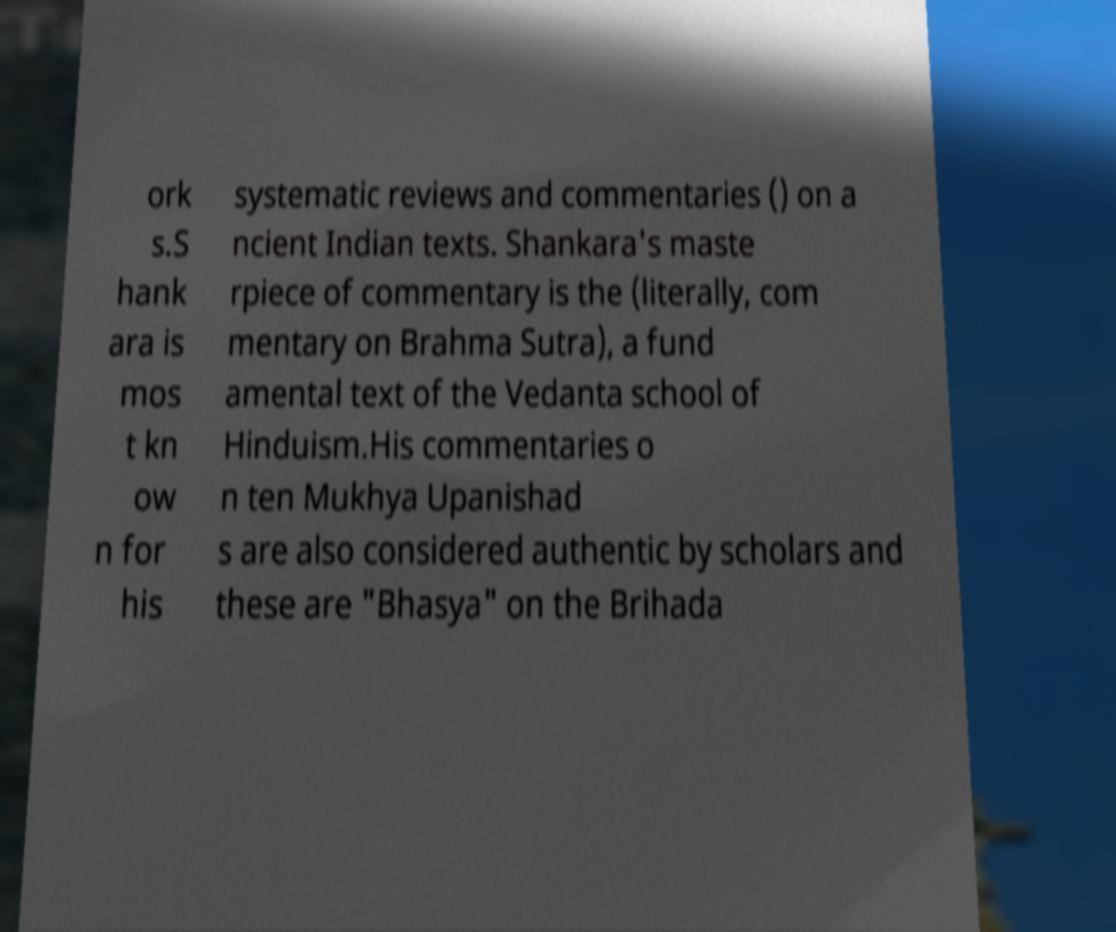Could you assist in decoding the text presented in this image and type it out clearly? ork s.S hank ara is mos t kn ow n for his systematic reviews and commentaries () on a ncient Indian texts. Shankara's maste rpiece of commentary is the (literally, com mentary on Brahma Sutra), a fund amental text of the Vedanta school of Hinduism.His commentaries o n ten Mukhya Upanishad s are also considered authentic by scholars and these are "Bhasya" on the Brihada 